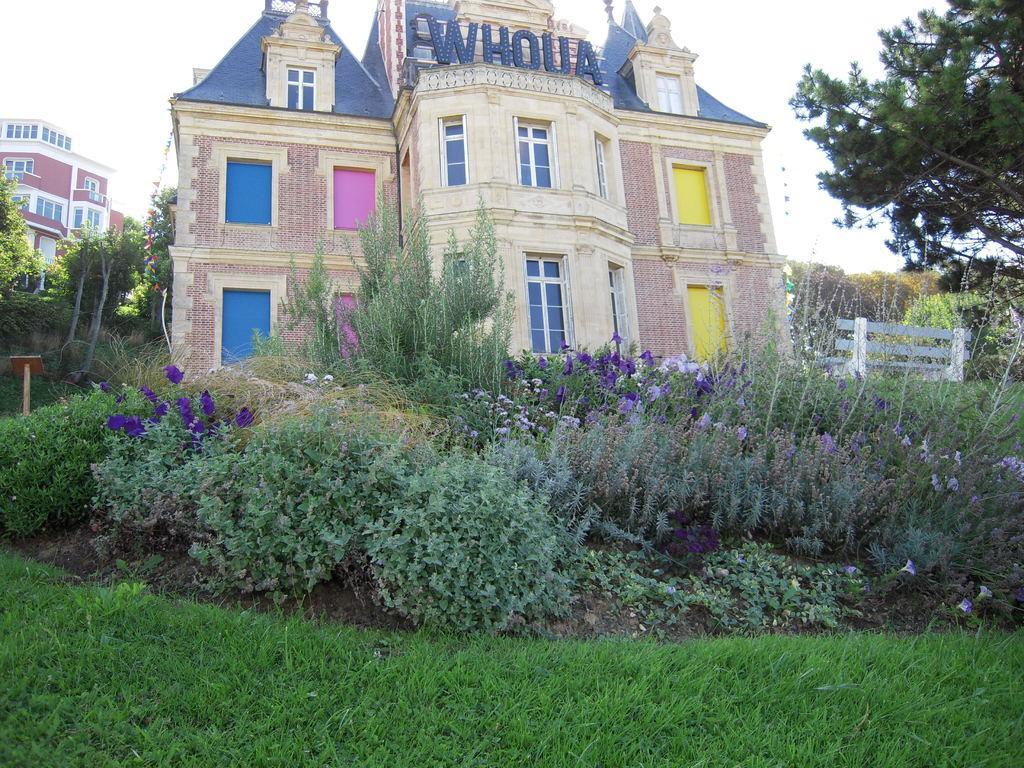In one or two sentences, can you explain what this image depicts? In this image we can see some grass, plants and in the background of the image there are some houses, trees and clear sky. 